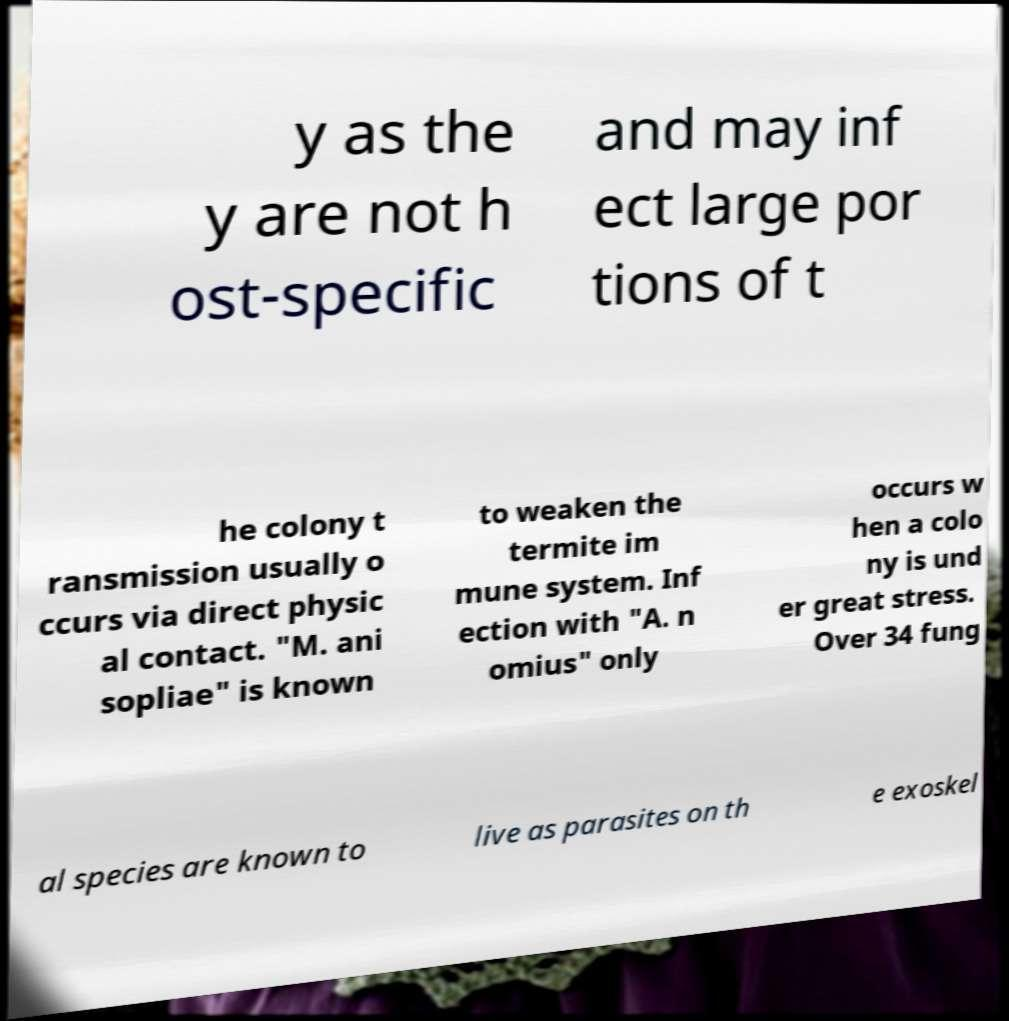For documentation purposes, I need the text within this image transcribed. Could you provide that? y as the y are not h ost-specific and may inf ect large por tions of t he colony t ransmission usually o ccurs via direct physic al contact. "M. ani sopliae" is known to weaken the termite im mune system. Inf ection with "A. n omius" only occurs w hen a colo ny is und er great stress. Over 34 fung al species are known to live as parasites on th e exoskel 